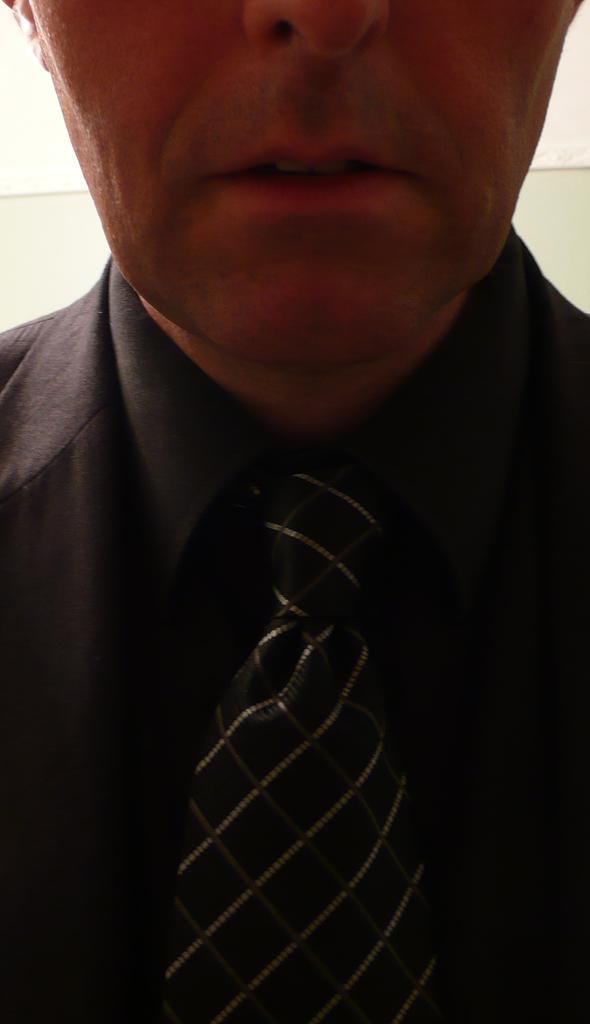What is the main subject of the image? The main subject of the image is a man. What is the man wearing in the image? The man is wearing a shirt and a tie in the image. What facial features of the man are visible in the image? The man's chin and mouth are visible in the image. How much was the payment for the man's tie in the image? There is no information about payment for the tie in the image. How many people are present in the image? The image only features one person, the man. What type of tooth can be seen in the man's mouth in the image? The man's mouth is visible in the image, but there is no specific tooth that can be identified. 